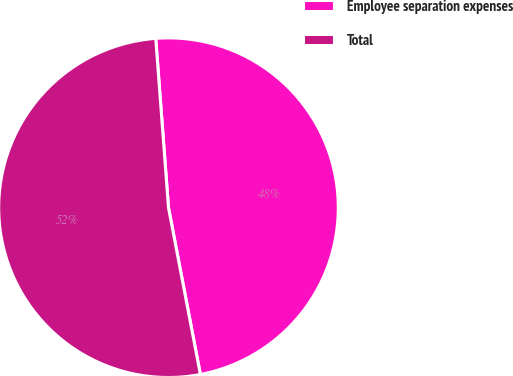Convert chart to OTSL. <chart><loc_0><loc_0><loc_500><loc_500><pie_chart><fcel>Employee separation expenses<fcel>Total<nl><fcel>48.19%<fcel>51.81%<nl></chart> 